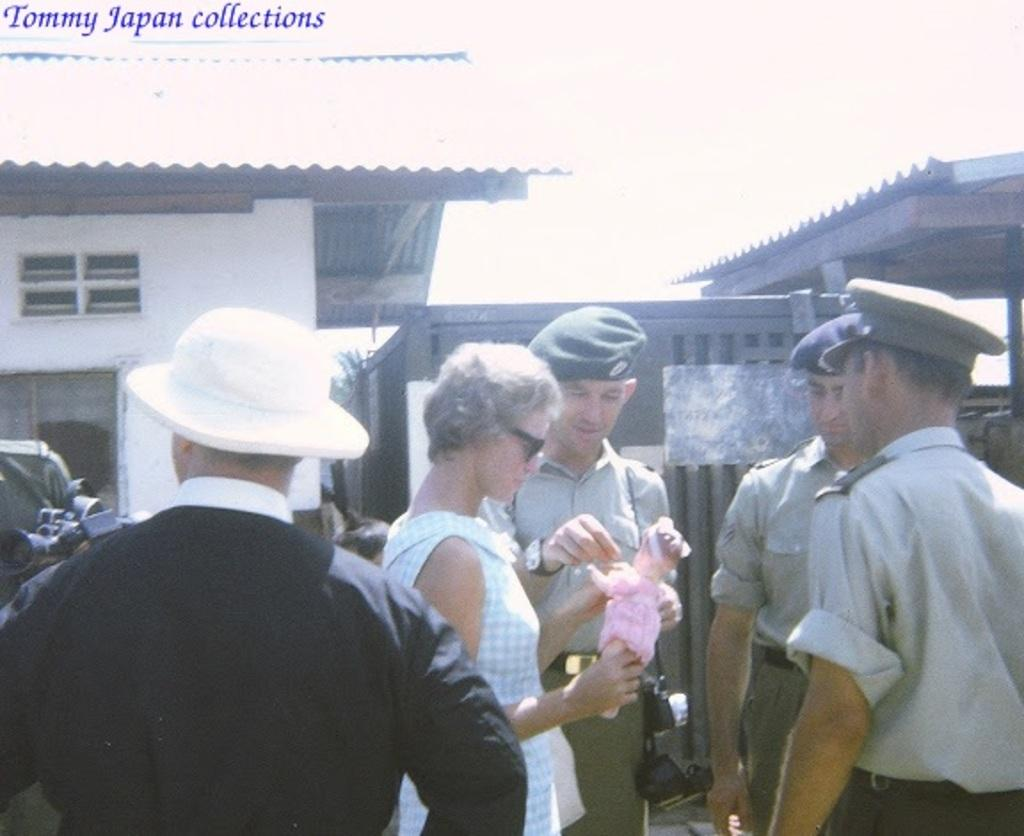What can be seen in the foreground of the image? There are people standing in the foreground of the image. What is visible in the background of the image? There are houses in the background of the image. Can you describe the clothing or accessories of some people in the image? Some people in the image are wearing caps. How does the root of the tree in the image help people learn? There is no tree present in the image, so the root of a tree cannot be observed or contribute to learning in this context. 